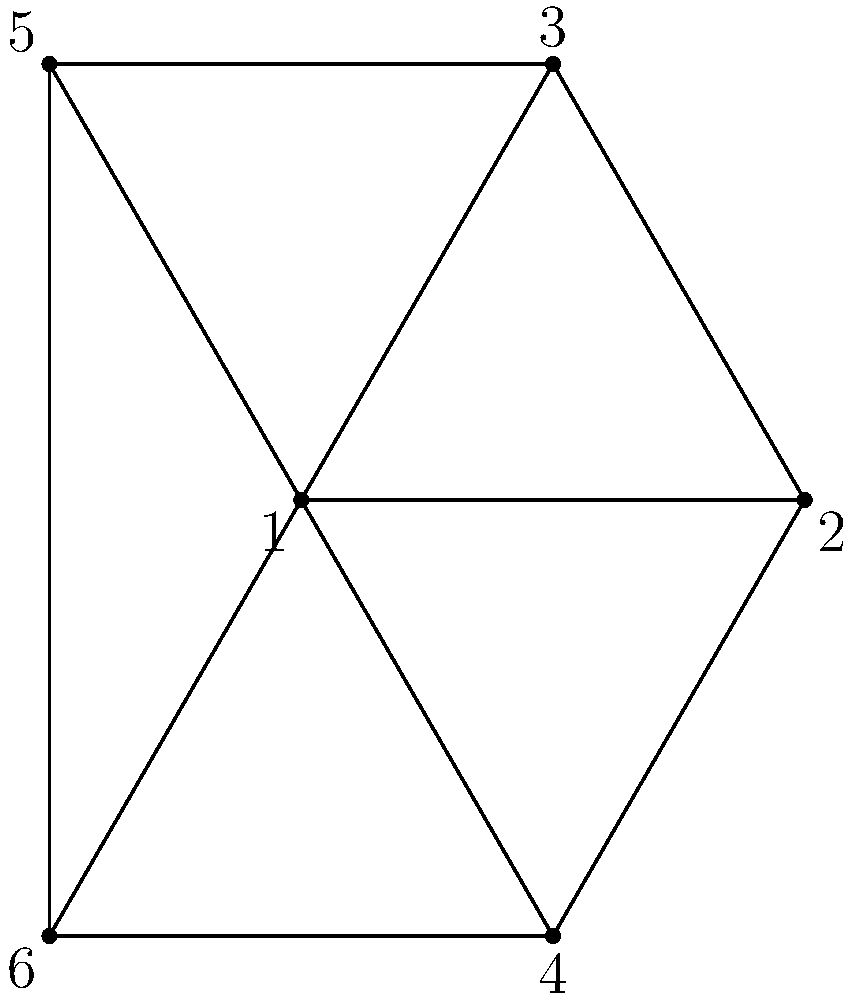Consider the planar graph shown above. What is the minimum number of colors required to properly color this graph, and how does this relate to the Four Color Theorem? Explain your reasoning, considering the graph's structure and any potential complications in the coloring process. To determine the minimum number of colors required to properly color this planar graph, we'll follow these steps:

1. Analyze the graph structure:
   The graph is planar and consists of 6 vertices, forming a wheel-like structure with a central vertex connected to all others.

2. Apply the Four Color Theorem:
   The Four Color Theorem states that any planar graph can be colored using at most four colors, such that no adjacent vertices share the same color.

3. Examine the graph's coloring requirements:
   a. The central vertex (1) is adjacent to all other vertices.
   b. Vertices 2, 3, 4, 5, and 6 form a cycle around the central vertex.

4. Determine the minimum number of colors:
   a. Assign color A to the central vertex (1).
   b. The remaining vertices form an odd cycle of length 5.
   c. An odd cycle requires at least 3 colors to be properly colored.
   d. We can color the outer cycle as follows:
      - Vertex 2: Color B
      - Vertex 3: Color C
      - Vertex 4: Color B
      - Vertex 5: Color C
      - Vertex 6: Color D

5. Verify the coloring:
   - No adjacent vertices share the same color.
   - We used 4 colors in total (A, B, C, and D).

6. Attempt to reduce the number of colors:
   - We cannot use fewer than 4 colors because:
     a. The central vertex needs a unique color.
     b. The odd cycle of length 5 requires at least 3 colors.

7. Relate to the Four Color Theorem:
   This graph demonstrates a case where exactly 4 colors are needed, which is the upper bound guaranteed by the Four Color Theorem for any planar graph.

Therefore, the minimum number of colors required to properly color this graph is 4, which aligns with the upper bound provided by the Four Color Theorem.
Answer: 4 colors 